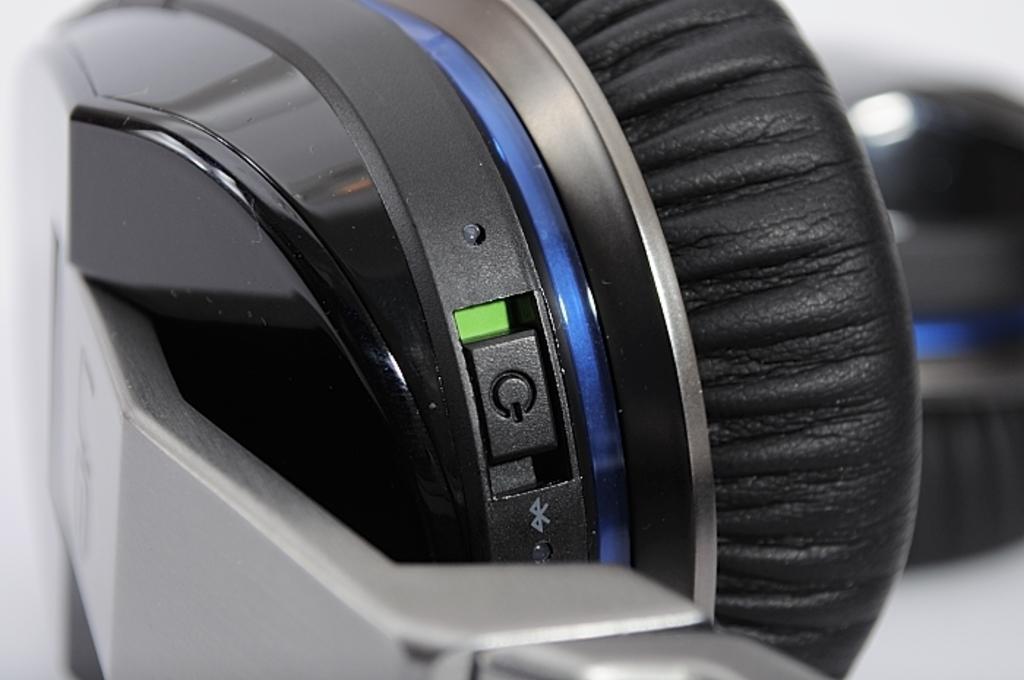How would you summarize this image in a sentence or two? In the picture we can see a part of a headset with a speaker which is black in color and to it we can see a power button with green color light. 